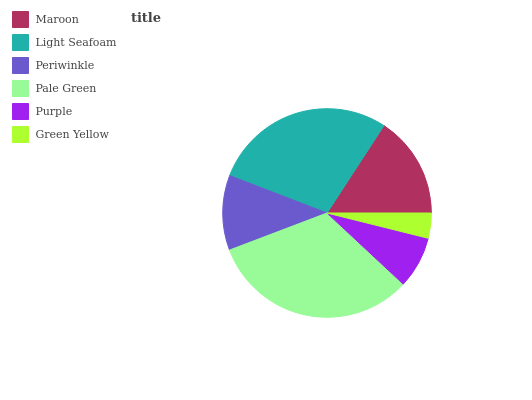Is Green Yellow the minimum?
Answer yes or no. Yes. Is Pale Green the maximum?
Answer yes or no. Yes. Is Light Seafoam the minimum?
Answer yes or no. No. Is Light Seafoam the maximum?
Answer yes or no. No. Is Light Seafoam greater than Maroon?
Answer yes or no. Yes. Is Maroon less than Light Seafoam?
Answer yes or no. Yes. Is Maroon greater than Light Seafoam?
Answer yes or no. No. Is Light Seafoam less than Maroon?
Answer yes or no. No. Is Maroon the high median?
Answer yes or no. Yes. Is Periwinkle the low median?
Answer yes or no. Yes. Is Light Seafoam the high median?
Answer yes or no. No. Is Purple the low median?
Answer yes or no. No. 